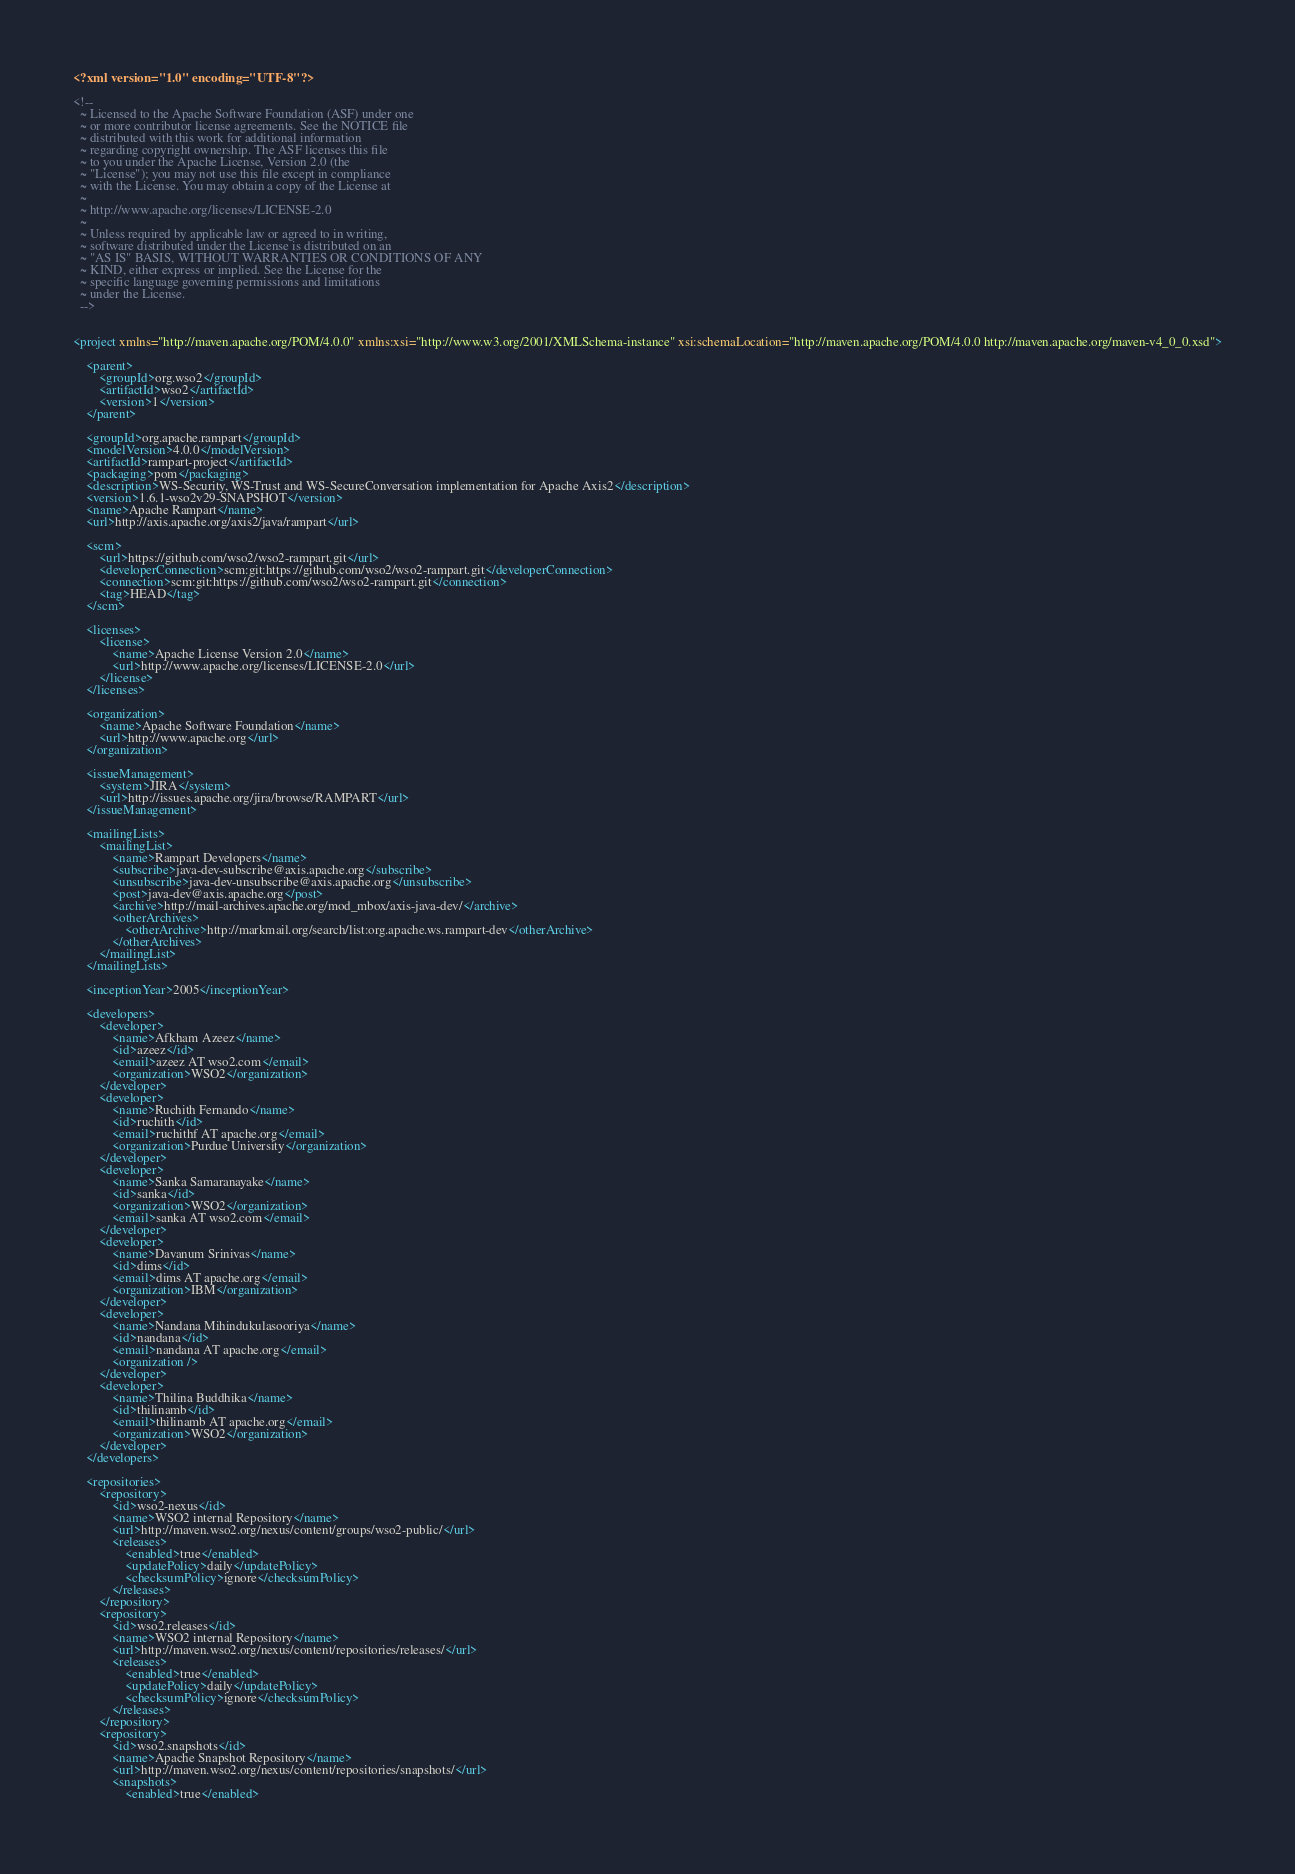<code> <loc_0><loc_0><loc_500><loc_500><_XML_><?xml version="1.0" encoding="UTF-8"?>

<!--
  ~ Licensed to the Apache Software Foundation (ASF) under one
  ~ or more contributor license agreements. See the NOTICE file
  ~ distributed with this work for additional information
  ~ regarding copyright ownership. The ASF licenses this file
  ~ to you under the Apache License, Version 2.0 (the
  ~ "License"); you may not use this file except in compliance
  ~ with the License. You may obtain a copy of the License at
  ~
  ~ http://www.apache.org/licenses/LICENSE-2.0
  ~
  ~ Unless required by applicable law or agreed to in writing,
  ~ software distributed under the License is distributed on an
  ~ "AS IS" BASIS, WITHOUT WARRANTIES OR CONDITIONS OF ANY
  ~ KIND, either express or implied. See the License for the
  ~ specific language governing permissions and limitations
  ~ under the License.
  -->


<project xmlns="http://maven.apache.org/POM/4.0.0" xmlns:xsi="http://www.w3.org/2001/XMLSchema-instance" xsi:schemaLocation="http://maven.apache.org/POM/4.0.0 http://maven.apache.org/maven-v4_0_0.xsd">

    <parent>
        <groupId>org.wso2</groupId>
        <artifactId>wso2</artifactId>
        <version>1</version>
    </parent>

    <groupId>org.apache.rampart</groupId>
    <modelVersion>4.0.0</modelVersion>
    <artifactId>rampart-project</artifactId>
    <packaging>pom</packaging>
    <description>WS-Security, WS-Trust and WS-SecureConversation implementation for Apache Axis2</description>
    <version>1.6.1-wso2v29-SNAPSHOT</version>
    <name>Apache Rampart</name>
    <url>http://axis.apache.org/axis2/java/rampart</url>

    <scm>
        <url>https://github.com/wso2/wso2-rampart.git</url>
        <developerConnection>scm:git:https://github.com/wso2/wso2-rampart.git</developerConnection>
        <connection>scm:git:https://github.com/wso2/wso2-rampart.git</connection>
        <tag>HEAD</tag>
    </scm>

    <licenses>
        <license>
            <name>Apache License Version 2.0</name>
            <url>http://www.apache.org/licenses/LICENSE-2.0</url>
        </license>
    </licenses>

    <organization>
        <name>Apache Software Foundation</name>
        <url>http://www.apache.org</url>
    </organization>

    <issueManagement>
        <system>JIRA</system>
        <url>http://issues.apache.org/jira/browse/RAMPART</url>
    </issueManagement>

    <mailingLists>
        <mailingList>
            <name>Rampart Developers</name>
            <subscribe>java-dev-subscribe@axis.apache.org</subscribe>
            <unsubscribe>java-dev-unsubscribe@axis.apache.org</unsubscribe>
            <post>java-dev@axis.apache.org</post>
            <archive>http://mail-archives.apache.org/mod_mbox/axis-java-dev/</archive>
            <otherArchives>
                <otherArchive>http://markmail.org/search/list:org.apache.ws.rampart-dev</otherArchive>
            </otherArchives>
        </mailingList>
    </mailingLists>

    <inceptionYear>2005</inceptionYear>

    <developers>
        <developer>
            <name>Afkham Azeez</name>
            <id>azeez</id>
            <email>azeez AT wso2.com</email>
            <organization>WSO2</organization>
        </developer>
        <developer>
            <name>Ruchith Fernando</name>
            <id>ruchith</id>
            <email>ruchithf AT apache.org</email>
            <organization>Purdue University</organization>
        </developer>
        <developer>
            <name>Sanka Samaranayake</name>
            <id>sanka</id>
            <organization>WSO2</organization>
            <email>sanka AT wso2.com</email>
        </developer>
        <developer>
            <name>Davanum Srinivas</name>
            <id>dims</id>
            <email>dims AT apache.org</email>
            <organization>IBM</organization>
        </developer>
        <developer>
            <name>Nandana Mihindukulasooriya</name>
            <id>nandana</id>
            <email>nandana AT apache.org</email>
            <organization />
        </developer>
        <developer>
            <name>Thilina Buddhika</name>
            <id>thilinamb</id>
            <email>thilinamb AT apache.org</email>
            <organization>WSO2</organization>
        </developer>
    </developers>

    <repositories>
        <repository>
            <id>wso2-nexus</id>
            <name>WSO2 internal Repository</name>
            <url>http://maven.wso2.org/nexus/content/groups/wso2-public/</url>
            <releases>
                <enabled>true</enabled>
                <updatePolicy>daily</updatePolicy>
                <checksumPolicy>ignore</checksumPolicy>
            </releases>
        </repository>
        <repository>
            <id>wso2.releases</id>
            <name>WSO2 internal Repository</name>
            <url>http://maven.wso2.org/nexus/content/repositories/releases/</url>
            <releases>
                <enabled>true</enabled>
                <updatePolicy>daily</updatePolicy>
                <checksumPolicy>ignore</checksumPolicy>
            </releases>
        </repository>
        <repository>
            <id>wso2.snapshots</id>
            <name>Apache Snapshot Repository</name>
            <url>http://maven.wso2.org/nexus/content/repositories/snapshots/</url>
            <snapshots>
                <enabled>true</enabled></code> 